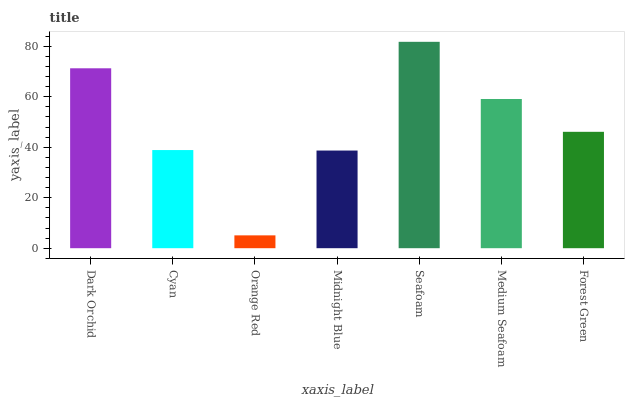Is Orange Red the minimum?
Answer yes or no. Yes. Is Seafoam the maximum?
Answer yes or no. Yes. Is Cyan the minimum?
Answer yes or no. No. Is Cyan the maximum?
Answer yes or no. No. Is Dark Orchid greater than Cyan?
Answer yes or no. Yes. Is Cyan less than Dark Orchid?
Answer yes or no. Yes. Is Cyan greater than Dark Orchid?
Answer yes or no. No. Is Dark Orchid less than Cyan?
Answer yes or no. No. Is Forest Green the high median?
Answer yes or no. Yes. Is Forest Green the low median?
Answer yes or no. Yes. Is Midnight Blue the high median?
Answer yes or no. No. Is Midnight Blue the low median?
Answer yes or no. No. 